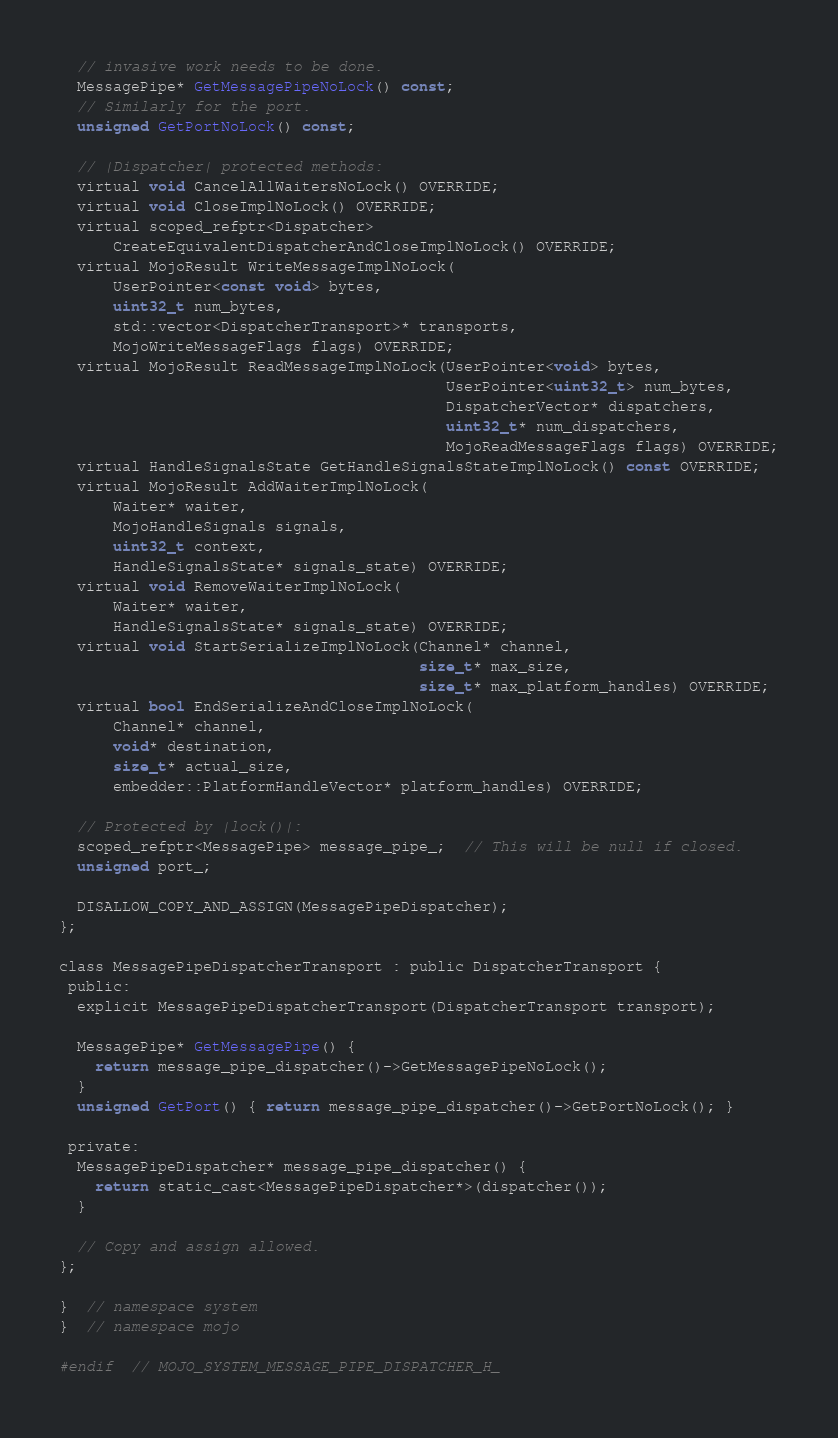Convert code to text. <code><loc_0><loc_0><loc_500><loc_500><_C_>  // invasive work needs to be done.
  MessagePipe* GetMessagePipeNoLock() const;
  // Similarly for the port.
  unsigned GetPortNoLock() const;

  // |Dispatcher| protected methods:
  virtual void CancelAllWaitersNoLock() OVERRIDE;
  virtual void CloseImplNoLock() OVERRIDE;
  virtual scoped_refptr<Dispatcher>
      CreateEquivalentDispatcherAndCloseImplNoLock() OVERRIDE;
  virtual MojoResult WriteMessageImplNoLock(
      UserPointer<const void> bytes,
      uint32_t num_bytes,
      std::vector<DispatcherTransport>* transports,
      MojoWriteMessageFlags flags) OVERRIDE;
  virtual MojoResult ReadMessageImplNoLock(UserPointer<void> bytes,
                                           UserPointer<uint32_t> num_bytes,
                                           DispatcherVector* dispatchers,
                                           uint32_t* num_dispatchers,
                                           MojoReadMessageFlags flags) OVERRIDE;
  virtual HandleSignalsState GetHandleSignalsStateImplNoLock() const OVERRIDE;
  virtual MojoResult AddWaiterImplNoLock(
      Waiter* waiter,
      MojoHandleSignals signals,
      uint32_t context,
      HandleSignalsState* signals_state) OVERRIDE;
  virtual void RemoveWaiterImplNoLock(
      Waiter* waiter,
      HandleSignalsState* signals_state) OVERRIDE;
  virtual void StartSerializeImplNoLock(Channel* channel,
                                        size_t* max_size,
                                        size_t* max_platform_handles) OVERRIDE;
  virtual bool EndSerializeAndCloseImplNoLock(
      Channel* channel,
      void* destination,
      size_t* actual_size,
      embedder::PlatformHandleVector* platform_handles) OVERRIDE;

  // Protected by |lock()|:
  scoped_refptr<MessagePipe> message_pipe_;  // This will be null if closed.
  unsigned port_;

  DISALLOW_COPY_AND_ASSIGN(MessagePipeDispatcher);
};

class MessagePipeDispatcherTransport : public DispatcherTransport {
 public:
  explicit MessagePipeDispatcherTransport(DispatcherTransport transport);

  MessagePipe* GetMessagePipe() {
    return message_pipe_dispatcher()->GetMessagePipeNoLock();
  }
  unsigned GetPort() { return message_pipe_dispatcher()->GetPortNoLock(); }

 private:
  MessagePipeDispatcher* message_pipe_dispatcher() {
    return static_cast<MessagePipeDispatcher*>(dispatcher());
  }

  // Copy and assign allowed.
};

}  // namespace system
}  // namespace mojo

#endif  // MOJO_SYSTEM_MESSAGE_PIPE_DISPATCHER_H_
</code> 